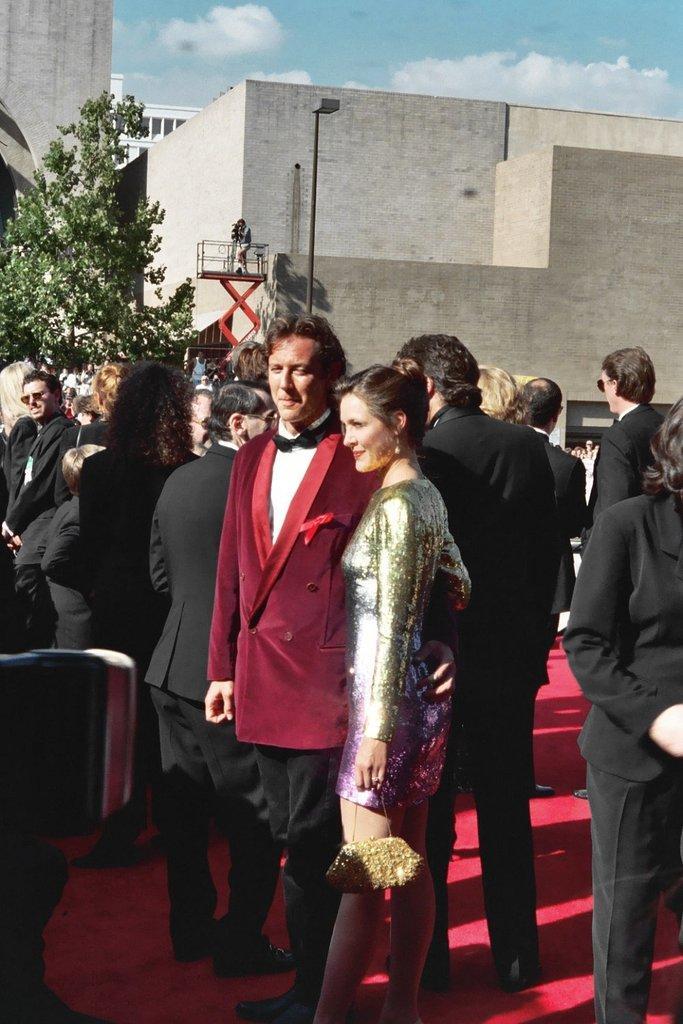In one or two sentences, can you explain what this image depicts? In this picture, there are group of people. In the center, there is a man and a woman. Man is wearing a red blazer and woman is holding a bag. Behind them, there are men wearing black blazers. At the bottom, there is a red carpet. On the top, there is a building, tree and a sky with clouds. 